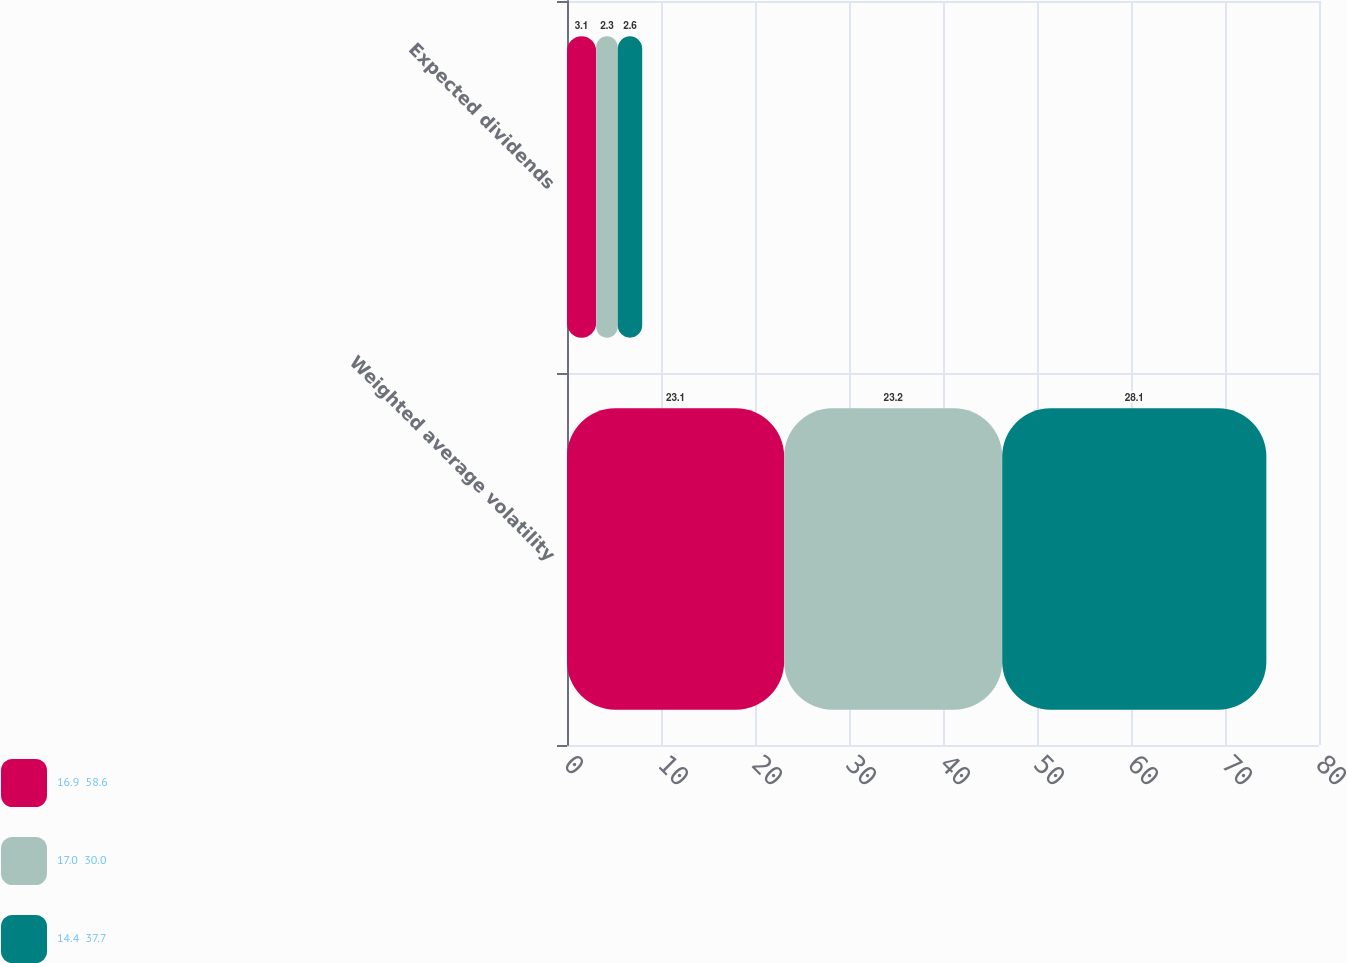<chart> <loc_0><loc_0><loc_500><loc_500><stacked_bar_chart><ecel><fcel>Weighted average volatility<fcel>Expected dividends<nl><fcel>16.9  58.6<fcel>23.1<fcel>3.1<nl><fcel>17.0  30.0<fcel>23.2<fcel>2.3<nl><fcel>14.4  37.7<fcel>28.1<fcel>2.6<nl></chart> 